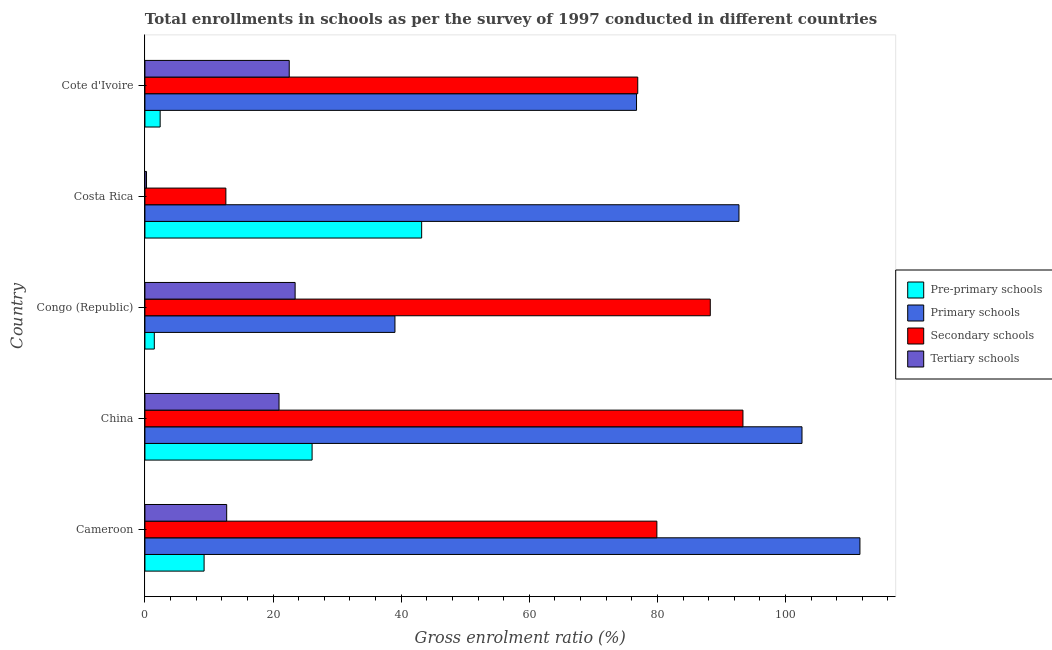How many different coloured bars are there?
Your answer should be compact. 4. How many groups of bars are there?
Ensure brevity in your answer.  5. Are the number of bars per tick equal to the number of legend labels?
Your answer should be very brief. Yes. How many bars are there on the 1st tick from the bottom?
Ensure brevity in your answer.  4. In how many cases, is the number of bars for a given country not equal to the number of legend labels?
Offer a terse response. 0. What is the gross enrolment ratio in pre-primary schools in Costa Rica?
Ensure brevity in your answer.  43.2. Across all countries, what is the maximum gross enrolment ratio in secondary schools?
Give a very brief answer. 93.36. Across all countries, what is the minimum gross enrolment ratio in tertiary schools?
Offer a terse response. 0.25. In which country was the gross enrolment ratio in tertiary schools maximum?
Your answer should be very brief. Congo (Republic). In which country was the gross enrolment ratio in pre-primary schools minimum?
Make the answer very short. Congo (Republic). What is the total gross enrolment ratio in pre-primary schools in the graph?
Make the answer very short. 82.38. What is the difference between the gross enrolment ratio in secondary schools in Congo (Republic) and that in Costa Rica?
Your answer should be compact. 75.62. What is the difference between the gross enrolment ratio in tertiary schools in Costa Rica and the gross enrolment ratio in secondary schools in China?
Provide a succinct answer. -93.11. What is the average gross enrolment ratio in pre-primary schools per country?
Provide a short and direct response. 16.48. What is the difference between the gross enrolment ratio in primary schools and gross enrolment ratio in secondary schools in Cameroon?
Give a very brief answer. 31.7. What is the ratio of the gross enrolment ratio in pre-primary schools in Cameroon to that in Cote d'Ivoire?
Give a very brief answer. 3.88. What is the difference between the highest and the lowest gross enrolment ratio in tertiary schools?
Provide a succinct answer. 23.2. Is it the case that in every country, the sum of the gross enrolment ratio in secondary schools and gross enrolment ratio in pre-primary schools is greater than the sum of gross enrolment ratio in tertiary schools and gross enrolment ratio in primary schools?
Keep it short and to the point. Yes. What does the 4th bar from the top in Cote d'Ivoire represents?
Offer a very short reply. Pre-primary schools. What does the 1st bar from the bottom in Cameroon represents?
Make the answer very short. Pre-primary schools. Is it the case that in every country, the sum of the gross enrolment ratio in pre-primary schools and gross enrolment ratio in primary schools is greater than the gross enrolment ratio in secondary schools?
Your answer should be compact. No. Where does the legend appear in the graph?
Give a very brief answer. Center right. How many legend labels are there?
Your answer should be compact. 4. What is the title of the graph?
Offer a very short reply. Total enrollments in schools as per the survey of 1997 conducted in different countries. What is the label or title of the X-axis?
Your answer should be compact. Gross enrolment ratio (%). What is the label or title of the Y-axis?
Ensure brevity in your answer.  Country. What is the Gross enrolment ratio (%) of Pre-primary schools in Cameroon?
Make the answer very short. 9.24. What is the Gross enrolment ratio (%) in Primary schools in Cameroon?
Offer a very short reply. 111.62. What is the Gross enrolment ratio (%) of Secondary schools in Cameroon?
Keep it short and to the point. 79.92. What is the Gross enrolment ratio (%) of Tertiary schools in Cameroon?
Keep it short and to the point. 12.76. What is the Gross enrolment ratio (%) of Pre-primary schools in China?
Ensure brevity in your answer.  26.1. What is the Gross enrolment ratio (%) of Primary schools in China?
Your response must be concise. 102.58. What is the Gross enrolment ratio (%) of Secondary schools in China?
Provide a succinct answer. 93.36. What is the Gross enrolment ratio (%) in Tertiary schools in China?
Your answer should be very brief. 20.94. What is the Gross enrolment ratio (%) in Pre-primary schools in Congo (Republic)?
Your answer should be compact. 1.47. What is the Gross enrolment ratio (%) in Primary schools in Congo (Republic)?
Your answer should be very brief. 39.03. What is the Gross enrolment ratio (%) in Secondary schools in Congo (Republic)?
Provide a short and direct response. 88.26. What is the Gross enrolment ratio (%) in Tertiary schools in Congo (Republic)?
Provide a succinct answer. 23.45. What is the Gross enrolment ratio (%) in Pre-primary schools in Costa Rica?
Provide a succinct answer. 43.2. What is the Gross enrolment ratio (%) in Primary schools in Costa Rica?
Your answer should be very brief. 92.74. What is the Gross enrolment ratio (%) of Secondary schools in Costa Rica?
Offer a terse response. 12.64. What is the Gross enrolment ratio (%) of Tertiary schools in Costa Rica?
Give a very brief answer. 0.25. What is the Gross enrolment ratio (%) in Pre-primary schools in Cote d'Ivoire?
Your answer should be very brief. 2.38. What is the Gross enrolment ratio (%) in Primary schools in Cote d'Ivoire?
Your answer should be compact. 76.75. What is the Gross enrolment ratio (%) in Secondary schools in Cote d'Ivoire?
Give a very brief answer. 76.94. What is the Gross enrolment ratio (%) of Tertiary schools in Cote d'Ivoire?
Ensure brevity in your answer.  22.53. Across all countries, what is the maximum Gross enrolment ratio (%) in Pre-primary schools?
Your response must be concise. 43.2. Across all countries, what is the maximum Gross enrolment ratio (%) of Primary schools?
Make the answer very short. 111.62. Across all countries, what is the maximum Gross enrolment ratio (%) of Secondary schools?
Ensure brevity in your answer.  93.36. Across all countries, what is the maximum Gross enrolment ratio (%) of Tertiary schools?
Ensure brevity in your answer.  23.45. Across all countries, what is the minimum Gross enrolment ratio (%) in Pre-primary schools?
Provide a succinct answer. 1.47. Across all countries, what is the minimum Gross enrolment ratio (%) of Primary schools?
Ensure brevity in your answer.  39.03. Across all countries, what is the minimum Gross enrolment ratio (%) of Secondary schools?
Your response must be concise. 12.64. Across all countries, what is the minimum Gross enrolment ratio (%) in Tertiary schools?
Your response must be concise. 0.25. What is the total Gross enrolment ratio (%) of Pre-primary schools in the graph?
Give a very brief answer. 82.38. What is the total Gross enrolment ratio (%) of Primary schools in the graph?
Provide a succinct answer. 422.72. What is the total Gross enrolment ratio (%) of Secondary schools in the graph?
Provide a succinct answer. 351.11. What is the total Gross enrolment ratio (%) of Tertiary schools in the graph?
Offer a terse response. 79.92. What is the difference between the Gross enrolment ratio (%) of Pre-primary schools in Cameroon and that in China?
Provide a succinct answer. -16.86. What is the difference between the Gross enrolment ratio (%) in Primary schools in Cameroon and that in China?
Provide a short and direct response. 9.05. What is the difference between the Gross enrolment ratio (%) in Secondary schools in Cameroon and that in China?
Provide a short and direct response. -13.44. What is the difference between the Gross enrolment ratio (%) in Tertiary schools in Cameroon and that in China?
Offer a terse response. -8.17. What is the difference between the Gross enrolment ratio (%) in Pre-primary schools in Cameroon and that in Congo (Republic)?
Make the answer very short. 7.77. What is the difference between the Gross enrolment ratio (%) of Primary schools in Cameroon and that in Congo (Republic)?
Keep it short and to the point. 72.59. What is the difference between the Gross enrolment ratio (%) in Secondary schools in Cameroon and that in Congo (Republic)?
Your answer should be compact. -8.34. What is the difference between the Gross enrolment ratio (%) in Tertiary schools in Cameroon and that in Congo (Republic)?
Your response must be concise. -10.68. What is the difference between the Gross enrolment ratio (%) of Pre-primary schools in Cameroon and that in Costa Rica?
Keep it short and to the point. -33.96. What is the difference between the Gross enrolment ratio (%) in Primary schools in Cameroon and that in Costa Rica?
Your response must be concise. 18.89. What is the difference between the Gross enrolment ratio (%) of Secondary schools in Cameroon and that in Costa Rica?
Offer a terse response. 67.29. What is the difference between the Gross enrolment ratio (%) of Tertiary schools in Cameroon and that in Costa Rica?
Your response must be concise. 12.52. What is the difference between the Gross enrolment ratio (%) of Pre-primary schools in Cameroon and that in Cote d'Ivoire?
Your response must be concise. 6.86. What is the difference between the Gross enrolment ratio (%) of Primary schools in Cameroon and that in Cote d'Ivoire?
Ensure brevity in your answer.  34.88. What is the difference between the Gross enrolment ratio (%) of Secondary schools in Cameroon and that in Cote d'Ivoire?
Ensure brevity in your answer.  2.99. What is the difference between the Gross enrolment ratio (%) in Tertiary schools in Cameroon and that in Cote d'Ivoire?
Your answer should be compact. -9.76. What is the difference between the Gross enrolment ratio (%) in Pre-primary schools in China and that in Congo (Republic)?
Make the answer very short. 24.63. What is the difference between the Gross enrolment ratio (%) of Primary schools in China and that in Congo (Republic)?
Provide a short and direct response. 63.54. What is the difference between the Gross enrolment ratio (%) in Secondary schools in China and that in Congo (Republic)?
Offer a very short reply. 5.1. What is the difference between the Gross enrolment ratio (%) of Tertiary schools in China and that in Congo (Republic)?
Offer a terse response. -2.51. What is the difference between the Gross enrolment ratio (%) in Pre-primary schools in China and that in Costa Rica?
Keep it short and to the point. -17.1. What is the difference between the Gross enrolment ratio (%) of Primary schools in China and that in Costa Rica?
Ensure brevity in your answer.  9.84. What is the difference between the Gross enrolment ratio (%) of Secondary schools in China and that in Costa Rica?
Ensure brevity in your answer.  80.72. What is the difference between the Gross enrolment ratio (%) in Tertiary schools in China and that in Costa Rica?
Ensure brevity in your answer.  20.69. What is the difference between the Gross enrolment ratio (%) of Pre-primary schools in China and that in Cote d'Ivoire?
Offer a terse response. 23.72. What is the difference between the Gross enrolment ratio (%) in Primary schools in China and that in Cote d'Ivoire?
Your response must be concise. 25.83. What is the difference between the Gross enrolment ratio (%) of Secondary schools in China and that in Cote d'Ivoire?
Provide a short and direct response. 16.42. What is the difference between the Gross enrolment ratio (%) in Tertiary schools in China and that in Cote d'Ivoire?
Ensure brevity in your answer.  -1.59. What is the difference between the Gross enrolment ratio (%) in Pre-primary schools in Congo (Republic) and that in Costa Rica?
Give a very brief answer. -41.74. What is the difference between the Gross enrolment ratio (%) in Primary schools in Congo (Republic) and that in Costa Rica?
Your answer should be very brief. -53.7. What is the difference between the Gross enrolment ratio (%) in Secondary schools in Congo (Republic) and that in Costa Rica?
Ensure brevity in your answer.  75.62. What is the difference between the Gross enrolment ratio (%) in Tertiary schools in Congo (Republic) and that in Costa Rica?
Keep it short and to the point. 23.2. What is the difference between the Gross enrolment ratio (%) of Pre-primary schools in Congo (Republic) and that in Cote d'Ivoire?
Ensure brevity in your answer.  -0.91. What is the difference between the Gross enrolment ratio (%) in Primary schools in Congo (Republic) and that in Cote d'Ivoire?
Your response must be concise. -37.71. What is the difference between the Gross enrolment ratio (%) in Secondary schools in Congo (Republic) and that in Cote d'Ivoire?
Offer a terse response. 11.32. What is the difference between the Gross enrolment ratio (%) of Pre-primary schools in Costa Rica and that in Cote d'Ivoire?
Make the answer very short. 40.82. What is the difference between the Gross enrolment ratio (%) in Primary schools in Costa Rica and that in Cote d'Ivoire?
Offer a terse response. 15.99. What is the difference between the Gross enrolment ratio (%) of Secondary schools in Costa Rica and that in Cote d'Ivoire?
Your response must be concise. -64.3. What is the difference between the Gross enrolment ratio (%) in Tertiary schools in Costa Rica and that in Cote d'Ivoire?
Your response must be concise. -22.28. What is the difference between the Gross enrolment ratio (%) of Pre-primary schools in Cameroon and the Gross enrolment ratio (%) of Primary schools in China?
Provide a succinct answer. -93.34. What is the difference between the Gross enrolment ratio (%) in Pre-primary schools in Cameroon and the Gross enrolment ratio (%) in Secondary schools in China?
Your answer should be compact. -84.12. What is the difference between the Gross enrolment ratio (%) of Pre-primary schools in Cameroon and the Gross enrolment ratio (%) of Tertiary schools in China?
Your answer should be compact. -11.7. What is the difference between the Gross enrolment ratio (%) in Primary schools in Cameroon and the Gross enrolment ratio (%) in Secondary schools in China?
Keep it short and to the point. 18.26. What is the difference between the Gross enrolment ratio (%) of Primary schools in Cameroon and the Gross enrolment ratio (%) of Tertiary schools in China?
Keep it short and to the point. 90.69. What is the difference between the Gross enrolment ratio (%) of Secondary schools in Cameroon and the Gross enrolment ratio (%) of Tertiary schools in China?
Your answer should be very brief. 58.99. What is the difference between the Gross enrolment ratio (%) in Pre-primary schools in Cameroon and the Gross enrolment ratio (%) in Primary schools in Congo (Republic)?
Ensure brevity in your answer.  -29.8. What is the difference between the Gross enrolment ratio (%) of Pre-primary schools in Cameroon and the Gross enrolment ratio (%) of Secondary schools in Congo (Republic)?
Offer a terse response. -79.02. What is the difference between the Gross enrolment ratio (%) of Pre-primary schools in Cameroon and the Gross enrolment ratio (%) of Tertiary schools in Congo (Republic)?
Make the answer very short. -14.21. What is the difference between the Gross enrolment ratio (%) in Primary schools in Cameroon and the Gross enrolment ratio (%) in Secondary schools in Congo (Republic)?
Give a very brief answer. 23.37. What is the difference between the Gross enrolment ratio (%) in Primary schools in Cameroon and the Gross enrolment ratio (%) in Tertiary schools in Congo (Republic)?
Provide a short and direct response. 88.18. What is the difference between the Gross enrolment ratio (%) of Secondary schools in Cameroon and the Gross enrolment ratio (%) of Tertiary schools in Congo (Republic)?
Ensure brevity in your answer.  56.47. What is the difference between the Gross enrolment ratio (%) of Pre-primary schools in Cameroon and the Gross enrolment ratio (%) of Primary schools in Costa Rica?
Ensure brevity in your answer.  -83.5. What is the difference between the Gross enrolment ratio (%) of Pre-primary schools in Cameroon and the Gross enrolment ratio (%) of Secondary schools in Costa Rica?
Your response must be concise. -3.4. What is the difference between the Gross enrolment ratio (%) in Pre-primary schools in Cameroon and the Gross enrolment ratio (%) in Tertiary schools in Costa Rica?
Provide a succinct answer. 8.99. What is the difference between the Gross enrolment ratio (%) of Primary schools in Cameroon and the Gross enrolment ratio (%) of Secondary schools in Costa Rica?
Provide a succinct answer. 98.99. What is the difference between the Gross enrolment ratio (%) of Primary schools in Cameroon and the Gross enrolment ratio (%) of Tertiary schools in Costa Rica?
Ensure brevity in your answer.  111.38. What is the difference between the Gross enrolment ratio (%) in Secondary schools in Cameroon and the Gross enrolment ratio (%) in Tertiary schools in Costa Rica?
Make the answer very short. 79.67. What is the difference between the Gross enrolment ratio (%) in Pre-primary schools in Cameroon and the Gross enrolment ratio (%) in Primary schools in Cote d'Ivoire?
Your answer should be very brief. -67.51. What is the difference between the Gross enrolment ratio (%) in Pre-primary schools in Cameroon and the Gross enrolment ratio (%) in Secondary schools in Cote d'Ivoire?
Your answer should be compact. -67.7. What is the difference between the Gross enrolment ratio (%) in Pre-primary schools in Cameroon and the Gross enrolment ratio (%) in Tertiary schools in Cote d'Ivoire?
Your response must be concise. -13.29. What is the difference between the Gross enrolment ratio (%) in Primary schools in Cameroon and the Gross enrolment ratio (%) in Secondary schools in Cote d'Ivoire?
Provide a succinct answer. 34.69. What is the difference between the Gross enrolment ratio (%) of Primary schools in Cameroon and the Gross enrolment ratio (%) of Tertiary schools in Cote d'Ivoire?
Your response must be concise. 89.1. What is the difference between the Gross enrolment ratio (%) of Secondary schools in Cameroon and the Gross enrolment ratio (%) of Tertiary schools in Cote d'Ivoire?
Make the answer very short. 57.39. What is the difference between the Gross enrolment ratio (%) of Pre-primary schools in China and the Gross enrolment ratio (%) of Primary schools in Congo (Republic)?
Keep it short and to the point. -12.94. What is the difference between the Gross enrolment ratio (%) of Pre-primary schools in China and the Gross enrolment ratio (%) of Secondary schools in Congo (Republic)?
Provide a short and direct response. -62.16. What is the difference between the Gross enrolment ratio (%) in Pre-primary schools in China and the Gross enrolment ratio (%) in Tertiary schools in Congo (Republic)?
Keep it short and to the point. 2.65. What is the difference between the Gross enrolment ratio (%) of Primary schools in China and the Gross enrolment ratio (%) of Secondary schools in Congo (Republic)?
Keep it short and to the point. 14.32. What is the difference between the Gross enrolment ratio (%) of Primary schools in China and the Gross enrolment ratio (%) of Tertiary schools in Congo (Republic)?
Your answer should be compact. 79.13. What is the difference between the Gross enrolment ratio (%) in Secondary schools in China and the Gross enrolment ratio (%) in Tertiary schools in Congo (Republic)?
Provide a succinct answer. 69.91. What is the difference between the Gross enrolment ratio (%) of Pre-primary schools in China and the Gross enrolment ratio (%) of Primary schools in Costa Rica?
Your answer should be very brief. -66.64. What is the difference between the Gross enrolment ratio (%) in Pre-primary schools in China and the Gross enrolment ratio (%) in Secondary schools in Costa Rica?
Keep it short and to the point. 13.46. What is the difference between the Gross enrolment ratio (%) in Pre-primary schools in China and the Gross enrolment ratio (%) in Tertiary schools in Costa Rica?
Make the answer very short. 25.85. What is the difference between the Gross enrolment ratio (%) in Primary schools in China and the Gross enrolment ratio (%) in Secondary schools in Costa Rica?
Your answer should be compact. 89.94. What is the difference between the Gross enrolment ratio (%) in Primary schools in China and the Gross enrolment ratio (%) in Tertiary schools in Costa Rica?
Offer a very short reply. 102.33. What is the difference between the Gross enrolment ratio (%) in Secondary schools in China and the Gross enrolment ratio (%) in Tertiary schools in Costa Rica?
Offer a terse response. 93.11. What is the difference between the Gross enrolment ratio (%) of Pre-primary schools in China and the Gross enrolment ratio (%) of Primary schools in Cote d'Ivoire?
Ensure brevity in your answer.  -50.65. What is the difference between the Gross enrolment ratio (%) of Pre-primary schools in China and the Gross enrolment ratio (%) of Secondary schools in Cote d'Ivoire?
Provide a short and direct response. -50.84. What is the difference between the Gross enrolment ratio (%) in Pre-primary schools in China and the Gross enrolment ratio (%) in Tertiary schools in Cote d'Ivoire?
Your answer should be compact. 3.57. What is the difference between the Gross enrolment ratio (%) of Primary schools in China and the Gross enrolment ratio (%) of Secondary schools in Cote d'Ivoire?
Your answer should be very brief. 25.64. What is the difference between the Gross enrolment ratio (%) in Primary schools in China and the Gross enrolment ratio (%) in Tertiary schools in Cote d'Ivoire?
Provide a succinct answer. 80.05. What is the difference between the Gross enrolment ratio (%) in Secondary schools in China and the Gross enrolment ratio (%) in Tertiary schools in Cote d'Ivoire?
Your response must be concise. 70.83. What is the difference between the Gross enrolment ratio (%) in Pre-primary schools in Congo (Republic) and the Gross enrolment ratio (%) in Primary schools in Costa Rica?
Ensure brevity in your answer.  -91.27. What is the difference between the Gross enrolment ratio (%) in Pre-primary schools in Congo (Republic) and the Gross enrolment ratio (%) in Secondary schools in Costa Rica?
Provide a short and direct response. -11.17. What is the difference between the Gross enrolment ratio (%) in Pre-primary schools in Congo (Republic) and the Gross enrolment ratio (%) in Tertiary schools in Costa Rica?
Keep it short and to the point. 1.22. What is the difference between the Gross enrolment ratio (%) in Primary schools in Congo (Republic) and the Gross enrolment ratio (%) in Secondary schools in Costa Rica?
Offer a very short reply. 26.4. What is the difference between the Gross enrolment ratio (%) of Primary schools in Congo (Republic) and the Gross enrolment ratio (%) of Tertiary schools in Costa Rica?
Make the answer very short. 38.79. What is the difference between the Gross enrolment ratio (%) in Secondary schools in Congo (Republic) and the Gross enrolment ratio (%) in Tertiary schools in Costa Rica?
Make the answer very short. 88.01. What is the difference between the Gross enrolment ratio (%) in Pre-primary schools in Congo (Republic) and the Gross enrolment ratio (%) in Primary schools in Cote d'Ivoire?
Provide a succinct answer. -75.28. What is the difference between the Gross enrolment ratio (%) of Pre-primary schools in Congo (Republic) and the Gross enrolment ratio (%) of Secondary schools in Cote d'Ivoire?
Provide a short and direct response. -75.47. What is the difference between the Gross enrolment ratio (%) in Pre-primary schools in Congo (Republic) and the Gross enrolment ratio (%) in Tertiary schools in Cote d'Ivoire?
Your answer should be very brief. -21.06. What is the difference between the Gross enrolment ratio (%) of Primary schools in Congo (Republic) and the Gross enrolment ratio (%) of Secondary schools in Cote d'Ivoire?
Your answer should be very brief. -37.9. What is the difference between the Gross enrolment ratio (%) of Primary schools in Congo (Republic) and the Gross enrolment ratio (%) of Tertiary schools in Cote d'Ivoire?
Provide a short and direct response. 16.51. What is the difference between the Gross enrolment ratio (%) in Secondary schools in Congo (Republic) and the Gross enrolment ratio (%) in Tertiary schools in Cote d'Ivoire?
Offer a very short reply. 65.73. What is the difference between the Gross enrolment ratio (%) of Pre-primary schools in Costa Rica and the Gross enrolment ratio (%) of Primary schools in Cote d'Ivoire?
Offer a terse response. -33.54. What is the difference between the Gross enrolment ratio (%) of Pre-primary schools in Costa Rica and the Gross enrolment ratio (%) of Secondary schools in Cote d'Ivoire?
Your answer should be very brief. -33.73. What is the difference between the Gross enrolment ratio (%) in Pre-primary schools in Costa Rica and the Gross enrolment ratio (%) in Tertiary schools in Cote d'Ivoire?
Give a very brief answer. 20.67. What is the difference between the Gross enrolment ratio (%) in Primary schools in Costa Rica and the Gross enrolment ratio (%) in Secondary schools in Cote d'Ivoire?
Offer a terse response. 15.8. What is the difference between the Gross enrolment ratio (%) in Primary schools in Costa Rica and the Gross enrolment ratio (%) in Tertiary schools in Cote d'Ivoire?
Offer a terse response. 70.21. What is the difference between the Gross enrolment ratio (%) of Secondary schools in Costa Rica and the Gross enrolment ratio (%) of Tertiary schools in Cote d'Ivoire?
Ensure brevity in your answer.  -9.89. What is the average Gross enrolment ratio (%) in Pre-primary schools per country?
Keep it short and to the point. 16.48. What is the average Gross enrolment ratio (%) in Primary schools per country?
Provide a short and direct response. 84.54. What is the average Gross enrolment ratio (%) of Secondary schools per country?
Keep it short and to the point. 70.22. What is the average Gross enrolment ratio (%) in Tertiary schools per country?
Offer a terse response. 15.98. What is the difference between the Gross enrolment ratio (%) in Pre-primary schools and Gross enrolment ratio (%) in Primary schools in Cameroon?
Your answer should be very brief. -102.39. What is the difference between the Gross enrolment ratio (%) of Pre-primary schools and Gross enrolment ratio (%) of Secondary schools in Cameroon?
Provide a short and direct response. -70.68. What is the difference between the Gross enrolment ratio (%) of Pre-primary schools and Gross enrolment ratio (%) of Tertiary schools in Cameroon?
Make the answer very short. -3.53. What is the difference between the Gross enrolment ratio (%) in Primary schools and Gross enrolment ratio (%) in Secondary schools in Cameroon?
Offer a very short reply. 31.7. What is the difference between the Gross enrolment ratio (%) of Primary schools and Gross enrolment ratio (%) of Tertiary schools in Cameroon?
Ensure brevity in your answer.  98.86. What is the difference between the Gross enrolment ratio (%) in Secondary schools and Gross enrolment ratio (%) in Tertiary schools in Cameroon?
Your answer should be compact. 67.16. What is the difference between the Gross enrolment ratio (%) in Pre-primary schools and Gross enrolment ratio (%) in Primary schools in China?
Give a very brief answer. -76.48. What is the difference between the Gross enrolment ratio (%) in Pre-primary schools and Gross enrolment ratio (%) in Secondary schools in China?
Your answer should be very brief. -67.26. What is the difference between the Gross enrolment ratio (%) of Pre-primary schools and Gross enrolment ratio (%) of Tertiary schools in China?
Your response must be concise. 5.16. What is the difference between the Gross enrolment ratio (%) of Primary schools and Gross enrolment ratio (%) of Secondary schools in China?
Provide a succinct answer. 9.22. What is the difference between the Gross enrolment ratio (%) of Primary schools and Gross enrolment ratio (%) of Tertiary schools in China?
Your answer should be compact. 81.64. What is the difference between the Gross enrolment ratio (%) in Secondary schools and Gross enrolment ratio (%) in Tertiary schools in China?
Your answer should be compact. 72.42. What is the difference between the Gross enrolment ratio (%) in Pre-primary schools and Gross enrolment ratio (%) in Primary schools in Congo (Republic)?
Your answer should be very brief. -37.57. What is the difference between the Gross enrolment ratio (%) of Pre-primary schools and Gross enrolment ratio (%) of Secondary schools in Congo (Republic)?
Make the answer very short. -86.79. What is the difference between the Gross enrolment ratio (%) in Pre-primary schools and Gross enrolment ratio (%) in Tertiary schools in Congo (Republic)?
Your answer should be very brief. -21.98. What is the difference between the Gross enrolment ratio (%) in Primary schools and Gross enrolment ratio (%) in Secondary schools in Congo (Republic)?
Your answer should be very brief. -49.22. What is the difference between the Gross enrolment ratio (%) of Primary schools and Gross enrolment ratio (%) of Tertiary schools in Congo (Republic)?
Give a very brief answer. 15.59. What is the difference between the Gross enrolment ratio (%) of Secondary schools and Gross enrolment ratio (%) of Tertiary schools in Congo (Republic)?
Offer a terse response. 64.81. What is the difference between the Gross enrolment ratio (%) in Pre-primary schools and Gross enrolment ratio (%) in Primary schools in Costa Rica?
Offer a very short reply. -49.54. What is the difference between the Gross enrolment ratio (%) of Pre-primary schools and Gross enrolment ratio (%) of Secondary schools in Costa Rica?
Provide a succinct answer. 30.57. What is the difference between the Gross enrolment ratio (%) of Pre-primary schools and Gross enrolment ratio (%) of Tertiary schools in Costa Rica?
Your answer should be compact. 42.95. What is the difference between the Gross enrolment ratio (%) in Primary schools and Gross enrolment ratio (%) in Secondary schools in Costa Rica?
Give a very brief answer. 80.1. What is the difference between the Gross enrolment ratio (%) in Primary schools and Gross enrolment ratio (%) in Tertiary schools in Costa Rica?
Offer a terse response. 92.49. What is the difference between the Gross enrolment ratio (%) in Secondary schools and Gross enrolment ratio (%) in Tertiary schools in Costa Rica?
Your answer should be compact. 12.39. What is the difference between the Gross enrolment ratio (%) in Pre-primary schools and Gross enrolment ratio (%) in Primary schools in Cote d'Ivoire?
Your answer should be very brief. -74.37. What is the difference between the Gross enrolment ratio (%) of Pre-primary schools and Gross enrolment ratio (%) of Secondary schools in Cote d'Ivoire?
Ensure brevity in your answer.  -74.56. What is the difference between the Gross enrolment ratio (%) of Pre-primary schools and Gross enrolment ratio (%) of Tertiary schools in Cote d'Ivoire?
Provide a succinct answer. -20.15. What is the difference between the Gross enrolment ratio (%) in Primary schools and Gross enrolment ratio (%) in Secondary schools in Cote d'Ivoire?
Offer a very short reply. -0.19. What is the difference between the Gross enrolment ratio (%) of Primary schools and Gross enrolment ratio (%) of Tertiary schools in Cote d'Ivoire?
Keep it short and to the point. 54.22. What is the difference between the Gross enrolment ratio (%) of Secondary schools and Gross enrolment ratio (%) of Tertiary schools in Cote d'Ivoire?
Offer a terse response. 54.41. What is the ratio of the Gross enrolment ratio (%) of Pre-primary schools in Cameroon to that in China?
Make the answer very short. 0.35. What is the ratio of the Gross enrolment ratio (%) in Primary schools in Cameroon to that in China?
Give a very brief answer. 1.09. What is the ratio of the Gross enrolment ratio (%) of Secondary schools in Cameroon to that in China?
Your response must be concise. 0.86. What is the ratio of the Gross enrolment ratio (%) in Tertiary schools in Cameroon to that in China?
Provide a succinct answer. 0.61. What is the ratio of the Gross enrolment ratio (%) in Pre-primary schools in Cameroon to that in Congo (Republic)?
Ensure brevity in your answer.  6.3. What is the ratio of the Gross enrolment ratio (%) in Primary schools in Cameroon to that in Congo (Republic)?
Provide a short and direct response. 2.86. What is the ratio of the Gross enrolment ratio (%) in Secondary schools in Cameroon to that in Congo (Republic)?
Your answer should be compact. 0.91. What is the ratio of the Gross enrolment ratio (%) of Tertiary schools in Cameroon to that in Congo (Republic)?
Keep it short and to the point. 0.54. What is the ratio of the Gross enrolment ratio (%) in Pre-primary schools in Cameroon to that in Costa Rica?
Ensure brevity in your answer.  0.21. What is the ratio of the Gross enrolment ratio (%) of Primary schools in Cameroon to that in Costa Rica?
Your response must be concise. 1.2. What is the ratio of the Gross enrolment ratio (%) in Secondary schools in Cameroon to that in Costa Rica?
Your answer should be compact. 6.32. What is the ratio of the Gross enrolment ratio (%) in Tertiary schools in Cameroon to that in Costa Rica?
Provide a succinct answer. 51.28. What is the ratio of the Gross enrolment ratio (%) in Pre-primary schools in Cameroon to that in Cote d'Ivoire?
Give a very brief answer. 3.88. What is the ratio of the Gross enrolment ratio (%) in Primary schools in Cameroon to that in Cote d'Ivoire?
Provide a short and direct response. 1.45. What is the ratio of the Gross enrolment ratio (%) of Secondary schools in Cameroon to that in Cote d'Ivoire?
Your answer should be very brief. 1.04. What is the ratio of the Gross enrolment ratio (%) of Tertiary schools in Cameroon to that in Cote d'Ivoire?
Offer a very short reply. 0.57. What is the ratio of the Gross enrolment ratio (%) of Pre-primary schools in China to that in Congo (Republic)?
Keep it short and to the point. 17.79. What is the ratio of the Gross enrolment ratio (%) in Primary schools in China to that in Congo (Republic)?
Provide a short and direct response. 2.63. What is the ratio of the Gross enrolment ratio (%) in Secondary schools in China to that in Congo (Republic)?
Offer a very short reply. 1.06. What is the ratio of the Gross enrolment ratio (%) of Tertiary schools in China to that in Congo (Republic)?
Offer a terse response. 0.89. What is the ratio of the Gross enrolment ratio (%) in Pre-primary schools in China to that in Costa Rica?
Your answer should be compact. 0.6. What is the ratio of the Gross enrolment ratio (%) in Primary schools in China to that in Costa Rica?
Offer a very short reply. 1.11. What is the ratio of the Gross enrolment ratio (%) of Secondary schools in China to that in Costa Rica?
Give a very brief answer. 7.39. What is the ratio of the Gross enrolment ratio (%) in Tertiary schools in China to that in Costa Rica?
Make the answer very short. 84.11. What is the ratio of the Gross enrolment ratio (%) of Pre-primary schools in China to that in Cote d'Ivoire?
Ensure brevity in your answer.  10.97. What is the ratio of the Gross enrolment ratio (%) in Primary schools in China to that in Cote d'Ivoire?
Keep it short and to the point. 1.34. What is the ratio of the Gross enrolment ratio (%) in Secondary schools in China to that in Cote d'Ivoire?
Provide a short and direct response. 1.21. What is the ratio of the Gross enrolment ratio (%) of Tertiary schools in China to that in Cote d'Ivoire?
Your response must be concise. 0.93. What is the ratio of the Gross enrolment ratio (%) in Pre-primary schools in Congo (Republic) to that in Costa Rica?
Provide a short and direct response. 0.03. What is the ratio of the Gross enrolment ratio (%) in Primary schools in Congo (Republic) to that in Costa Rica?
Your response must be concise. 0.42. What is the ratio of the Gross enrolment ratio (%) in Secondary schools in Congo (Republic) to that in Costa Rica?
Give a very brief answer. 6.98. What is the ratio of the Gross enrolment ratio (%) of Tertiary schools in Congo (Republic) to that in Costa Rica?
Give a very brief answer. 94.21. What is the ratio of the Gross enrolment ratio (%) of Pre-primary schools in Congo (Republic) to that in Cote d'Ivoire?
Keep it short and to the point. 0.62. What is the ratio of the Gross enrolment ratio (%) in Primary schools in Congo (Republic) to that in Cote d'Ivoire?
Provide a succinct answer. 0.51. What is the ratio of the Gross enrolment ratio (%) of Secondary schools in Congo (Republic) to that in Cote d'Ivoire?
Your response must be concise. 1.15. What is the ratio of the Gross enrolment ratio (%) in Tertiary schools in Congo (Republic) to that in Cote d'Ivoire?
Your answer should be very brief. 1.04. What is the ratio of the Gross enrolment ratio (%) of Pre-primary schools in Costa Rica to that in Cote d'Ivoire?
Make the answer very short. 18.16. What is the ratio of the Gross enrolment ratio (%) in Primary schools in Costa Rica to that in Cote d'Ivoire?
Offer a terse response. 1.21. What is the ratio of the Gross enrolment ratio (%) of Secondary schools in Costa Rica to that in Cote d'Ivoire?
Provide a short and direct response. 0.16. What is the ratio of the Gross enrolment ratio (%) of Tertiary schools in Costa Rica to that in Cote d'Ivoire?
Provide a short and direct response. 0.01. What is the difference between the highest and the second highest Gross enrolment ratio (%) in Pre-primary schools?
Offer a terse response. 17.1. What is the difference between the highest and the second highest Gross enrolment ratio (%) in Primary schools?
Keep it short and to the point. 9.05. What is the difference between the highest and the second highest Gross enrolment ratio (%) in Secondary schools?
Provide a succinct answer. 5.1. What is the difference between the highest and the lowest Gross enrolment ratio (%) in Pre-primary schools?
Your answer should be compact. 41.74. What is the difference between the highest and the lowest Gross enrolment ratio (%) of Primary schools?
Offer a very short reply. 72.59. What is the difference between the highest and the lowest Gross enrolment ratio (%) in Secondary schools?
Provide a succinct answer. 80.72. What is the difference between the highest and the lowest Gross enrolment ratio (%) of Tertiary schools?
Ensure brevity in your answer.  23.2. 